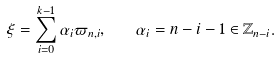Convert formula to latex. <formula><loc_0><loc_0><loc_500><loc_500>\xi = \sum _ { i = 0 } ^ { k - 1 } \alpha _ { i } \varpi _ { n , i } , \quad \alpha _ { i } = n - i - 1 \in \mathbb { Z } _ { n - i } .</formula> 